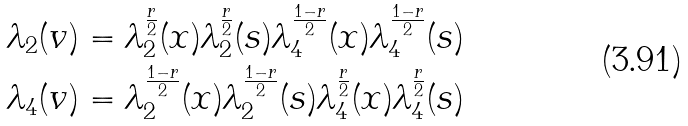<formula> <loc_0><loc_0><loc_500><loc_500>& \lambda _ { 2 } ( v ) = \lambda ^ { \frac { r } { 2 } } _ { 2 } ( x ) \lambda ^ { \frac { r } { 2 } } _ { 2 } ( s ) \lambda ^ { \frac { 1 - r } { 2 } } _ { 4 } ( x ) \lambda ^ { \frac { 1 - r } { 2 } } _ { 4 } ( s ) \\ & \lambda _ { 4 } ( v ) = \lambda ^ { \frac { 1 - r } { 2 } } _ { 2 } ( x ) \lambda ^ { \frac { 1 - r } { 2 } } _ { 2 } ( s ) \lambda ^ { \frac { r } { 2 } } _ { 4 } ( x ) \lambda ^ { \frac { r } { 2 } } _ { 4 } ( s )</formula> 